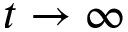<formula> <loc_0><loc_0><loc_500><loc_500>t \to \infty</formula> 